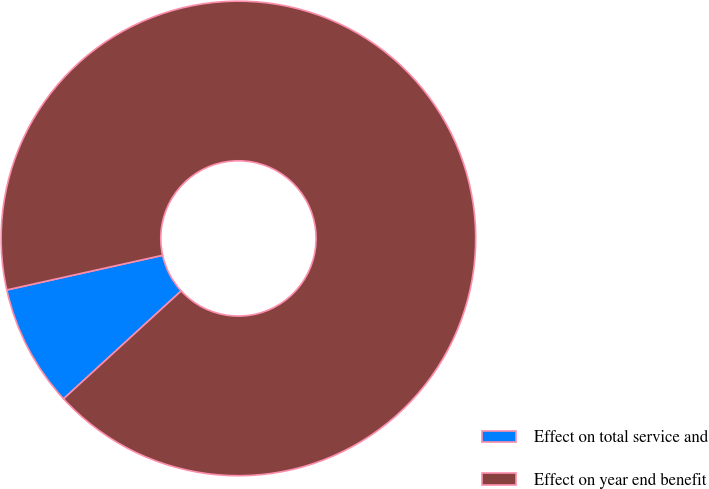Convert chart. <chart><loc_0><loc_0><loc_500><loc_500><pie_chart><fcel>Effect on total service and<fcel>Effect on year end benefit<nl><fcel>8.33%<fcel>91.67%<nl></chart> 